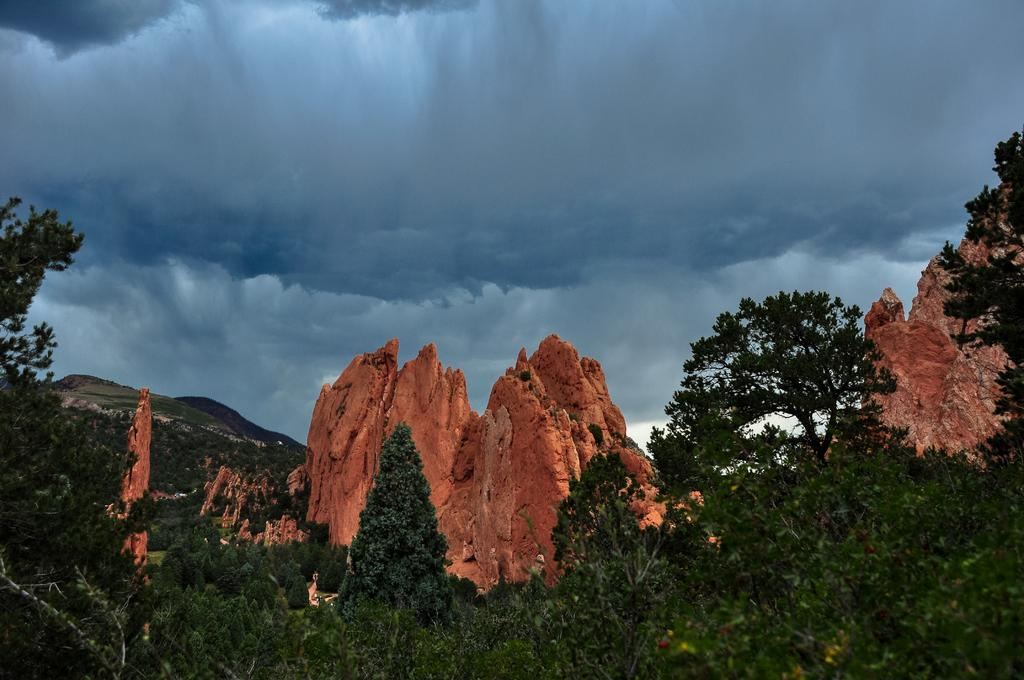What type of landscape can be seen in the image? The image appears to depict a forest. What geographical features are present in the image? There are hills and mountains in the image. What type of vegetation is visible in the image? There are trees with branches and leaves in the image. What can be seen in the sky in the image? Clouds are visible in the sky. Can you tell me how many needles are sticking out of the trees in the image? There are no needles present in the image; the trees have branches and leaves. How does the forest push the clouds in the image? The forest does not push the clouds in the image; the clouds are simply visible in the sky. 